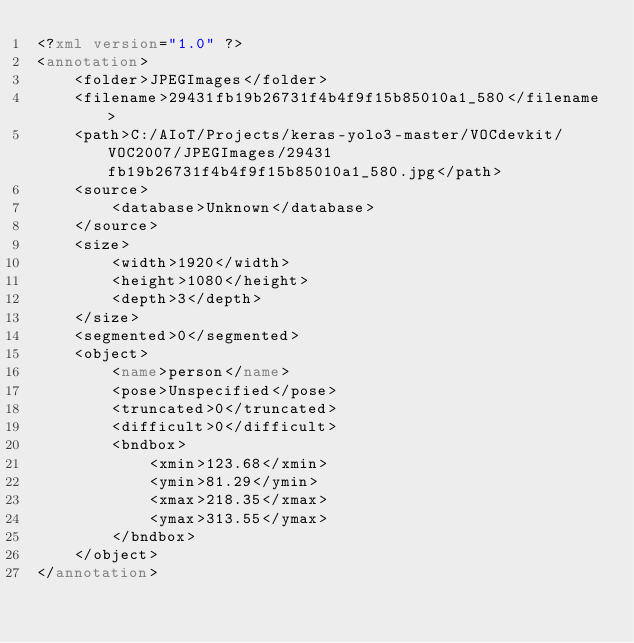<code> <loc_0><loc_0><loc_500><loc_500><_XML_><?xml version="1.0" ?>
<annotation>
	<folder>JPEGImages</folder>
	<filename>29431fb19b26731f4b4f9f15b85010a1_580</filename>
	<path>C:/AIoT/Projects/keras-yolo3-master/VOCdevkit/VOC2007/JPEGImages/29431fb19b26731f4b4f9f15b85010a1_580.jpg</path>
	<source>
		<database>Unknown</database>
	</source>
	<size>
		<width>1920</width>
		<height>1080</height>
		<depth>3</depth>
	</size>
	<segmented>0</segmented>
	<object>
		<name>person</name>
		<pose>Unspecified</pose>
		<truncated>0</truncated>
		<difficult>0</difficult>
		<bndbox>
			<xmin>123.68</xmin>
			<ymin>81.29</ymin>
			<xmax>218.35</xmax>
			<ymax>313.55</ymax>
		</bndbox>
	</object>
</annotation>
</code> 